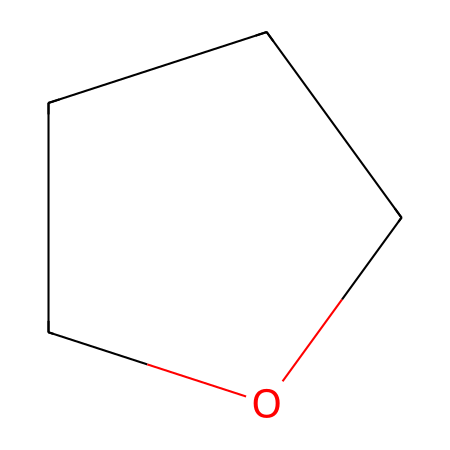What is the name of this chemical? The structure represented by the SMILES notation "C1CCCO1" corresponds to tetrahydrofuran, which is a cyclic ether.
Answer: tetrahydrofuran How many carbon atoms are in tetrahydrofuran? The SMILES indicates there are four carbon atoms (C) in the ring structure of tetrahydrofuran.
Answer: four What type of chemical bond primarily connects the carbon atoms in tetrahydrofuran? The carbon atoms in tetrahydrofuran are primarily connected by single covalent bonds, characteristic of ethers, where each carbon atom is bonded to neighboring atoms with single bonds.
Answer: single bonds What kind of functional group does tetrahydrofuran belong to? Tetrahydrofuran contains an ether functional group due to the presence of an oxygen atom connected between carbon atoms in a ring structure.
Answer: ether Considering its structure, how many oxygen atoms are in tetrahydrofuran? From the visual representation in the SMILES string, it is clear that there is one oxygen atom (O) present in the structure of tetrahydrofuran.
Answer: one What is the reactivity of tetrahydrofuran when used in adhesives? Tetrahydrofuran is known to be a polar aprotic solvent, which makes it effective in dissolving various polymers and adhesives, enhancing the bonding quality in repair applications.
Answer: polar aprotic solvent How does the ring structure of tetrahydrofuran influence its properties as a solvent? The cyclic structure of tetrahydrofuran provides stability while allowing it to maintain significant solvation properties due to its polar nature, impacting how it interacts with other components in adhesive formulations.
Answer: provides stability 